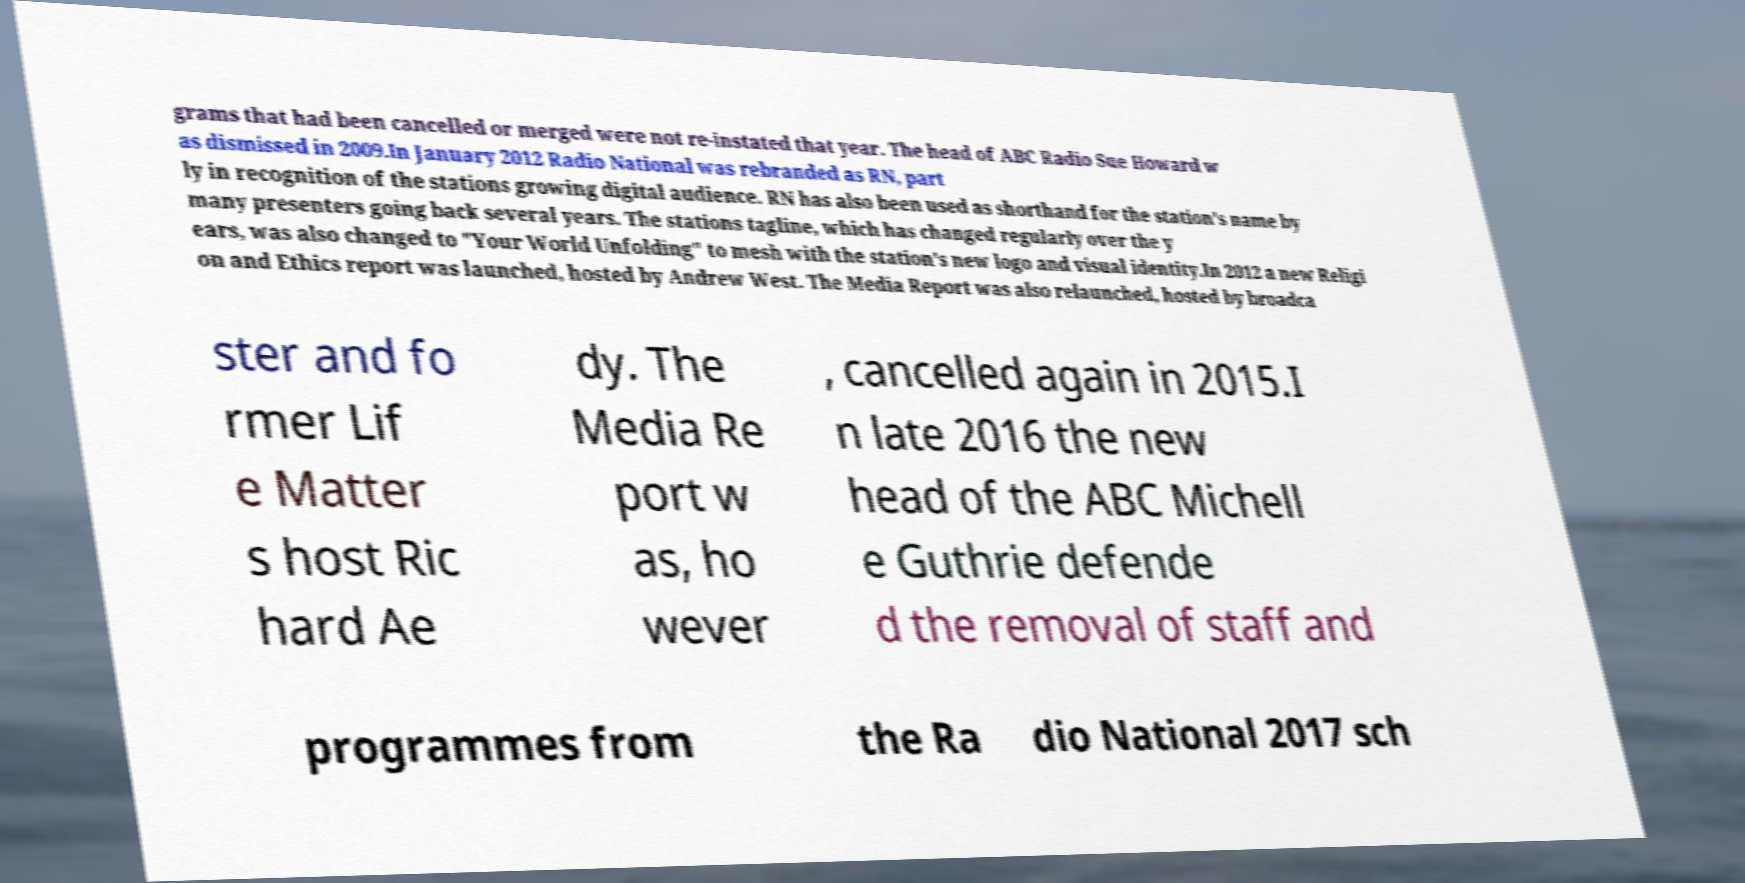There's text embedded in this image that I need extracted. Can you transcribe it verbatim? grams that had been cancelled or merged were not re-instated that year. The head of ABC Radio Sue Howard w as dismissed in 2009.In January 2012 Radio National was rebranded as RN, part ly in recognition of the stations growing digital audience. RN has also been used as shorthand for the station's name by many presenters going back several years. The stations tagline, which has changed regularly over the y ears, was also changed to "Your World Unfolding" to mesh with the station's new logo and visual identity.In 2012 a new Religi on and Ethics report was launched, hosted by Andrew West. The Media Report was also relaunched, hosted by broadca ster and fo rmer Lif e Matter s host Ric hard Ae dy. The Media Re port w as, ho wever , cancelled again in 2015.I n late 2016 the new head of the ABC Michell e Guthrie defende d the removal of staff and programmes from the Ra dio National 2017 sch 